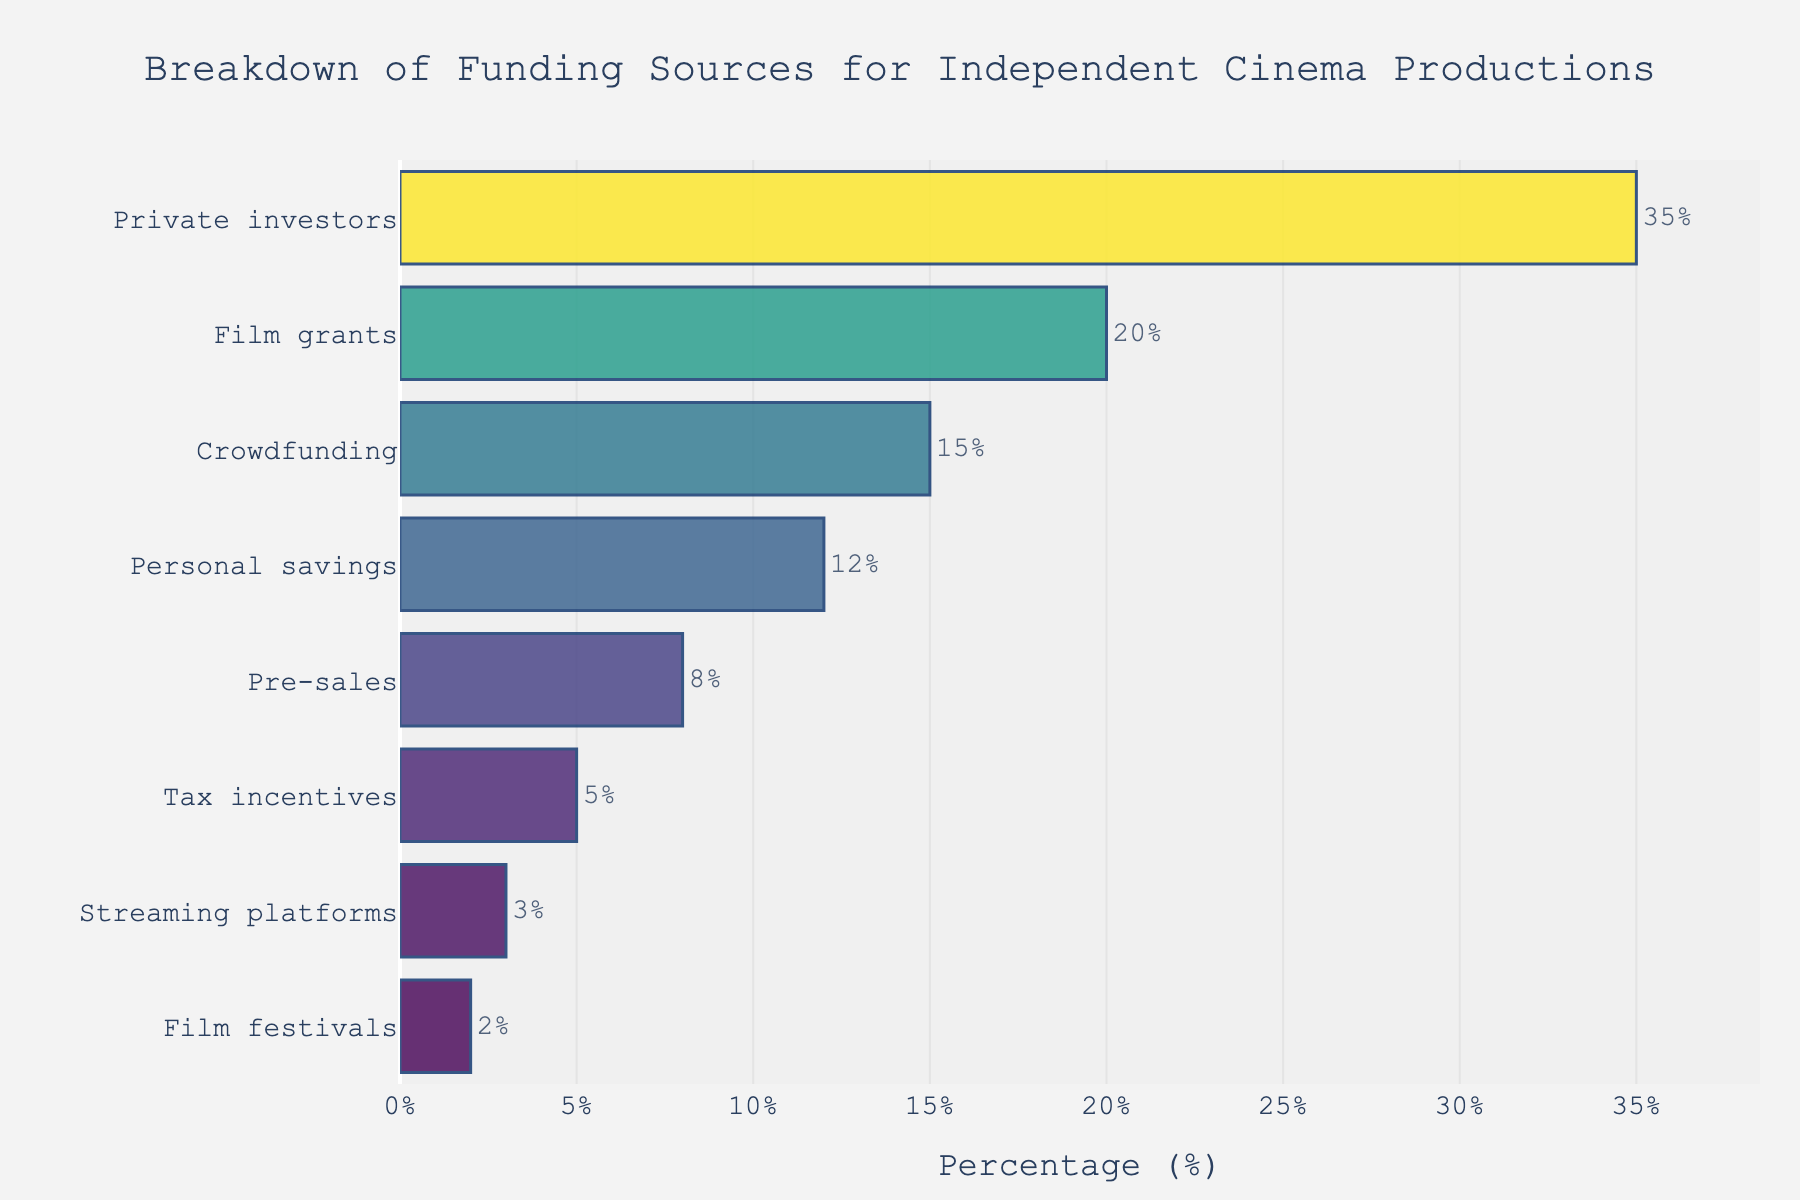What is the primary source of funding for independent cinema productions? The bar representing "Private investors" is the highest.
Answer: Private investors What is the combined percentage of funding from film grants and crowdfunding? The percentage for film grants is 20, and for crowdfunding, it is 15. Adding them together, 20 + 15 = 35.
Answer: 35% Which funding source provides a higher percentage, pre-sales or tax incentives? The bar for pre-sales shows 8%, while the bar for tax incentives shows 5%.
Answer: Pre-sales What is the least significant funding source? The smallest bar represents "Film festivals" with a percentage of 2%.
Answer: Film festivals How much more percentage is contributed by personal savings compared to pre-sales? Personal savings contribute 12%, and pre-sales contribute 8%. The difference is 12 - 8 = 4.
Answer: 4% Which funding sources contribute less than 10% each? The bars for pre-sales (8%), tax incentives (5%), streaming platforms (3%), and film festivals (2%) are all below 10%.
Answer: Pre-sales, tax incentives, streaming platforms, and film festivals What is the median percentage among all the funding sources? Arranging the percentages in ascending order: 2, 3, 5, 8, 12, 15, 20, 35. The median is the average of the 4th and 5th values: (8 + 12) / 2 = 10.
Answer: 10% Is the percentage for crowdfunding closer to the film grants or personal savings? Crowdfunding has 15%, film grants have 20%, and personal savings have 12%. The difference with film grants is 5 (20 - 15) and with personal savings is 3 (15 - 12). The closer value is to personal savings.
Answer: Personal savings What is the total percentage contributed by the top three funding sources? The top three funding sources are private investors (35%), film grants (20%), and crowdfunding (15%). Their sum is 35 + 20 + 15 = 70.
Answer: 70% 